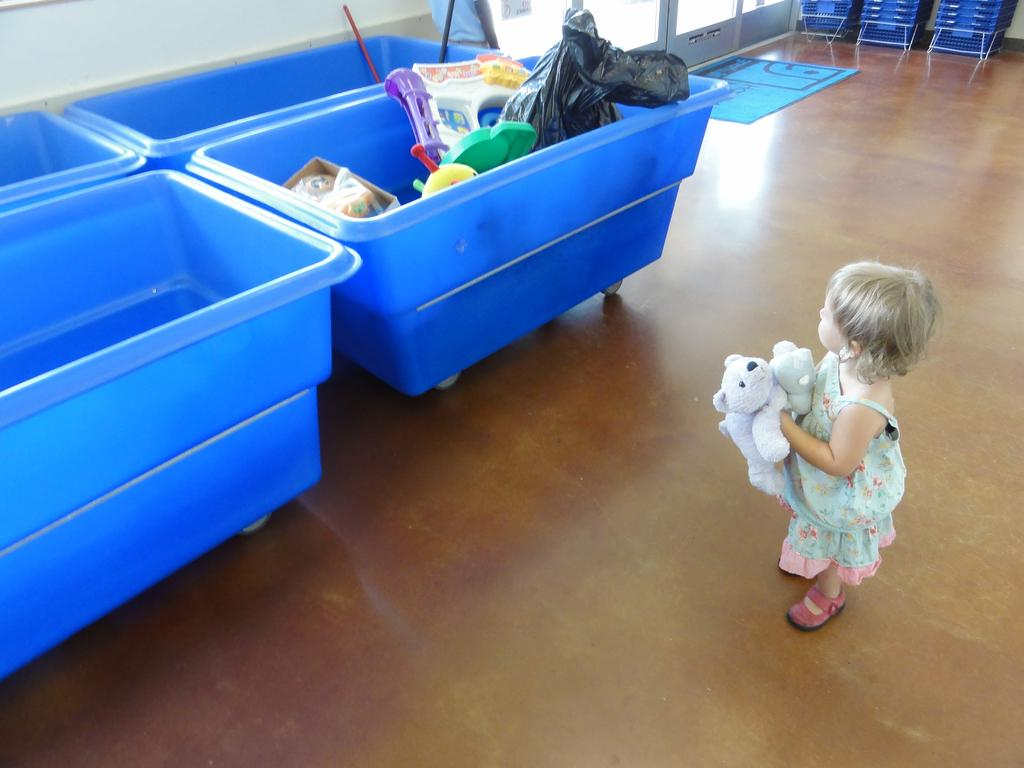What is the main subject of the image? The main subject of the image is a kid. What is the kid holding in the image? The kid is holding a toy. What type of containers can be seen in the image? There are storage containers in the image. What is the color of the mat in the image? The mat in the image is blue. What type of flooring is visible in the image? There is a wooden floor in the image. What type of bells can be heard ringing in the image? There are no bells present in the image, and therefore no sound can be heard. Is there a tub visible in the image? There is no tub visible in the image. 